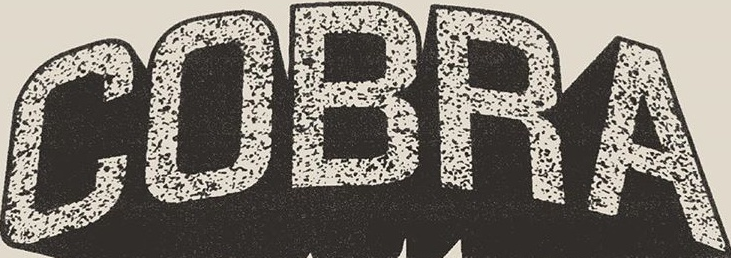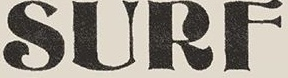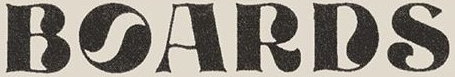Transcribe the words shown in these images in order, separated by a semicolon. COBRA; SURF; BOARDS 